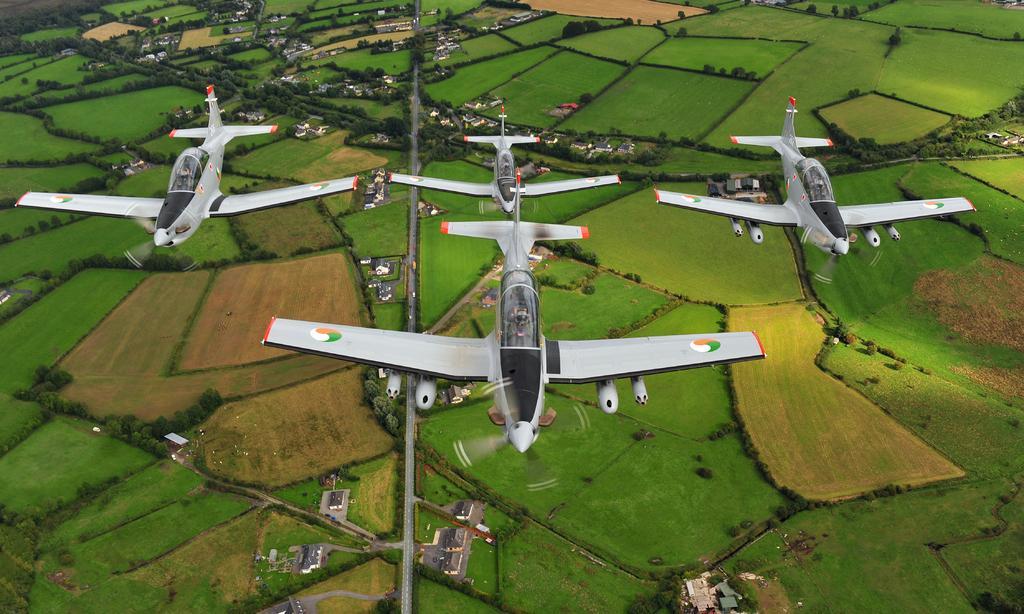Please provide a concise description of this image. In this image we can see planes are flying in the air. Here we can see ground, grass, plants, trees, roads, and houses. 